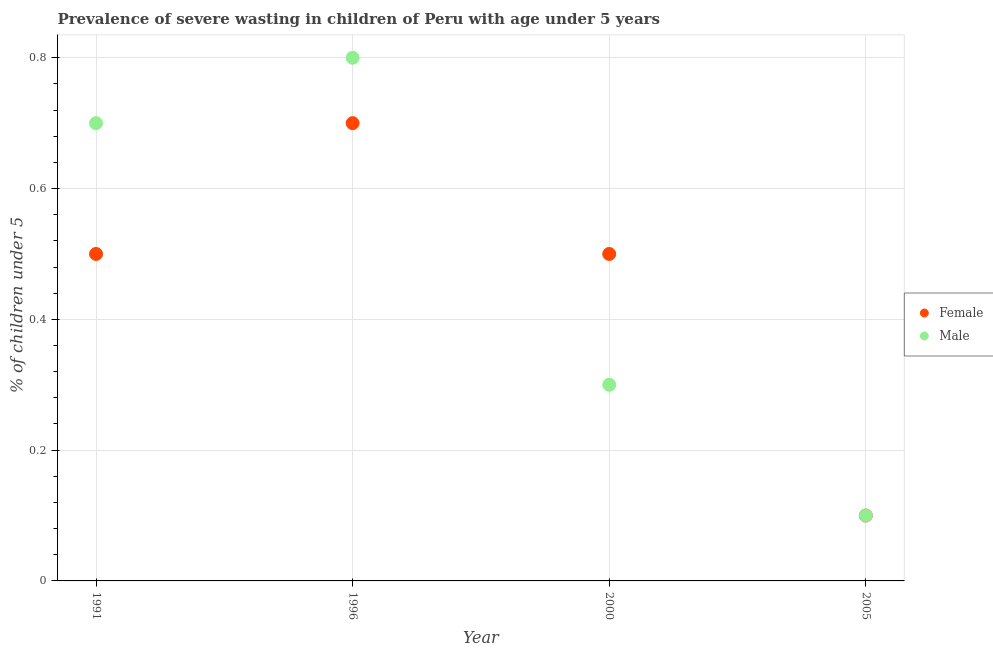Is the number of dotlines equal to the number of legend labels?
Provide a short and direct response. Yes. What is the percentage of undernourished male children in 2000?
Ensure brevity in your answer.  0.3. Across all years, what is the maximum percentage of undernourished male children?
Your answer should be very brief. 0.8. Across all years, what is the minimum percentage of undernourished male children?
Make the answer very short. 0.1. What is the total percentage of undernourished male children in the graph?
Keep it short and to the point. 1.9. What is the difference between the percentage of undernourished female children in 1991 and that in 2000?
Your answer should be very brief. 0. What is the difference between the percentage of undernourished male children in 1991 and the percentage of undernourished female children in 2005?
Keep it short and to the point. 0.6. What is the average percentage of undernourished female children per year?
Ensure brevity in your answer.  0.45. In the year 1991, what is the difference between the percentage of undernourished female children and percentage of undernourished male children?
Make the answer very short. -0.2. In how many years, is the percentage of undernourished female children greater than 0.32 %?
Give a very brief answer. 3. What is the ratio of the percentage of undernourished male children in 1991 to that in 1996?
Keep it short and to the point. 0.87. Is the percentage of undernourished female children in 1996 less than that in 2005?
Provide a succinct answer. No. Is the difference between the percentage of undernourished female children in 1996 and 2005 greater than the difference between the percentage of undernourished male children in 1996 and 2005?
Make the answer very short. No. What is the difference between the highest and the second highest percentage of undernourished female children?
Provide a succinct answer. 0.2. What is the difference between the highest and the lowest percentage of undernourished female children?
Keep it short and to the point. 0.6. In how many years, is the percentage of undernourished female children greater than the average percentage of undernourished female children taken over all years?
Provide a succinct answer. 3. Does the percentage of undernourished female children monotonically increase over the years?
Ensure brevity in your answer.  No. Is the percentage of undernourished male children strictly greater than the percentage of undernourished female children over the years?
Provide a short and direct response. No. Is the percentage of undernourished male children strictly less than the percentage of undernourished female children over the years?
Offer a very short reply. No. How many dotlines are there?
Your response must be concise. 2. What is the difference between two consecutive major ticks on the Y-axis?
Provide a short and direct response. 0.2. Are the values on the major ticks of Y-axis written in scientific E-notation?
Offer a terse response. No. Does the graph contain any zero values?
Give a very brief answer. No. Does the graph contain grids?
Provide a succinct answer. Yes. What is the title of the graph?
Offer a terse response. Prevalence of severe wasting in children of Peru with age under 5 years. What is the label or title of the X-axis?
Make the answer very short. Year. What is the label or title of the Y-axis?
Provide a succinct answer.  % of children under 5. What is the  % of children under 5 in Male in 1991?
Your answer should be compact. 0.7. What is the  % of children under 5 in Female in 1996?
Keep it short and to the point. 0.7. What is the  % of children under 5 in Male in 1996?
Provide a short and direct response. 0.8. What is the  % of children under 5 in Male in 2000?
Provide a succinct answer. 0.3. What is the  % of children under 5 in Female in 2005?
Offer a very short reply. 0.1. What is the  % of children under 5 of Male in 2005?
Your answer should be compact. 0.1. Across all years, what is the maximum  % of children under 5 of Female?
Ensure brevity in your answer.  0.7. Across all years, what is the maximum  % of children under 5 of Male?
Your answer should be compact. 0.8. Across all years, what is the minimum  % of children under 5 of Female?
Offer a very short reply. 0.1. Across all years, what is the minimum  % of children under 5 in Male?
Give a very brief answer. 0.1. What is the difference between the  % of children under 5 in Female in 1991 and that in 2000?
Provide a short and direct response. 0. What is the difference between the  % of children under 5 in Male in 1991 and that in 2000?
Keep it short and to the point. 0.4. What is the difference between the  % of children under 5 of Female in 1991 and that in 2005?
Keep it short and to the point. 0.4. What is the difference between the  % of children under 5 in Male in 1991 and that in 2005?
Ensure brevity in your answer.  0.6. What is the difference between the  % of children under 5 of Male in 1996 and that in 2000?
Your response must be concise. 0.5. What is the difference between the  % of children under 5 in Male in 2000 and that in 2005?
Ensure brevity in your answer.  0.2. What is the difference between the  % of children under 5 of Female in 1991 and the  % of children under 5 of Male in 2000?
Offer a very short reply. 0.2. What is the difference between the  % of children under 5 of Female in 1991 and the  % of children under 5 of Male in 2005?
Your response must be concise. 0.4. What is the difference between the  % of children under 5 of Female in 1996 and the  % of children under 5 of Male in 2005?
Provide a succinct answer. 0.6. What is the average  % of children under 5 in Female per year?
Offer a very short reply. 0.45. What is the average  % of children under 5 in Male per year?
Ensure brevity in your answer.  0.47. In the year 1991, what is the difference between the  % of children under 5 of Female and  % of children under 5 of Male?
Offer a terse response. -0.2. In the year 2000, what is the difference between the  % of children under 5 in Female and  % of children under 5 in Male?
Provide a succinct answer. 0.2. What is the ratio of the  % of children under 5 in Female in 1991 to that in 1996?
Offer a very short reply. 0.71. What is the ratio of the  % of children under 5 of Female in 1991 to that in 2000?
Give a very brief answer. 1. What is the ratio of the  % of children under 5 in Male in 1991 to that in 2000?
Provide a succinct answer. 2.33. What is the ratio of the  % of children under 5 of Female in 1991 to that in 2005?
Ensure brevity in your answer.  5. What is the ratio of the  % of children under 5 in Male in 1991 to that in 2005?
Make the answer very short. 7. What is the ratio of the  % of children under 5 in Female in 1996 to that in 2000?
Keep it short and to the point. 1.4. What is the ratio of the  % of children under 5 in Male in 1996 to that in 2000?
Provide a succinct answer. 2.67. What is the ratio of the  % of children under 5 in Male in 1996 to that in 2005?
Your answer should be compact. 8. What is the ratio of the  % of children under 5 in Female in 2000 to that in 2005?
Give a very brief answer. 5. What is the difference between the highest and the second highest  % of children under 5 of Female?
Give a very brief answer. 0.2. What is the difference between the highest and the lowest  % of children under 5 of Female?
Your answer should be very brief. 0.6. 